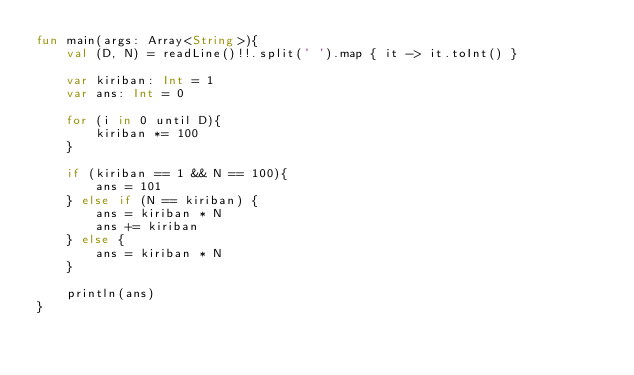Convert code to text. <code><loc_0><loc_0><loc_500><loc_500><_Kotlin_>fun main(args: Array<String>){
    val (D, N) = readLine()!!.split(' ').map { it -> it.toInt() }

    var kiriban: Int = 1
    var ans: Int = 0

    for (i in 0 until D){
        kiriban *= 100
    }
    
    if (kiriban == 1 && N == 100){
        ans = 101
    } else if (N == kiriban) {
        ans = kiriban * N
        ans += kiriban
    } else {
        ans = kiriban * N
    }

    println(ans)
}
</code> 